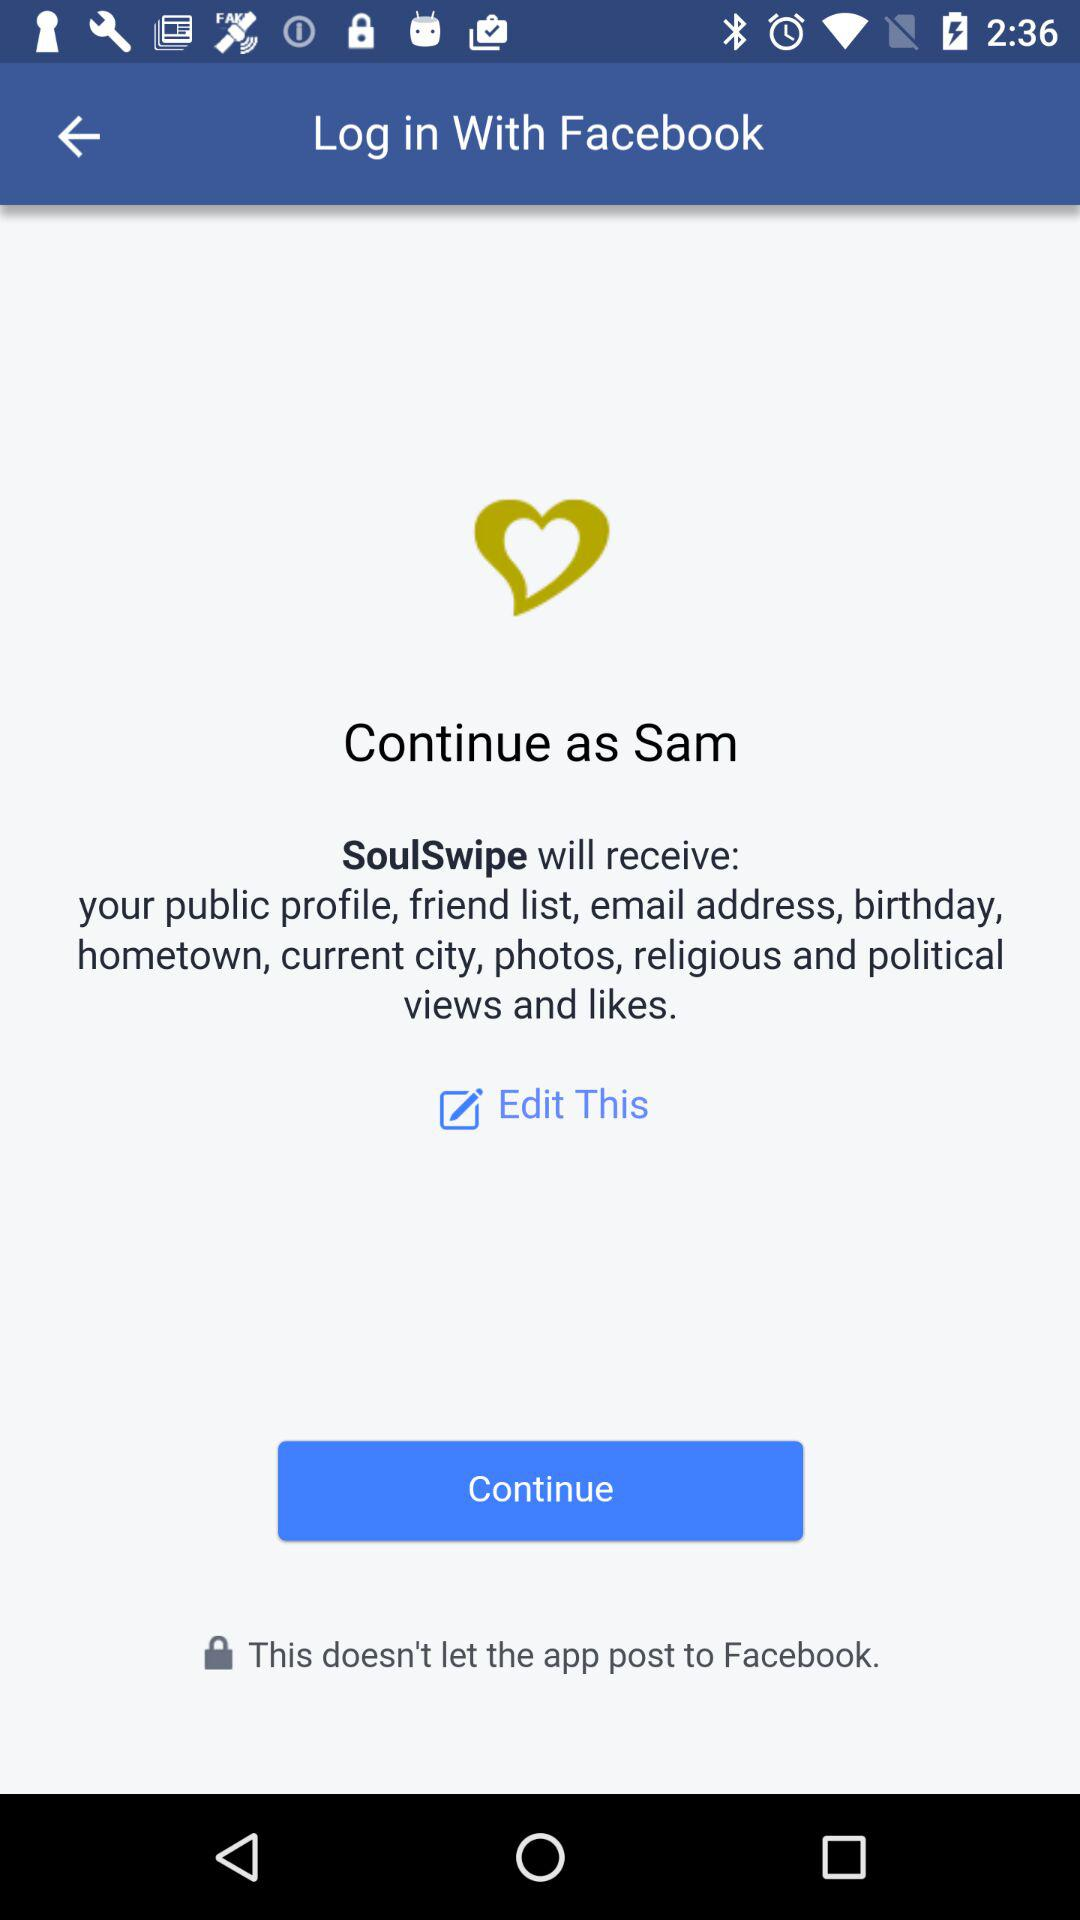Which application is in use? The application that is in use is "SoulSwipe". 